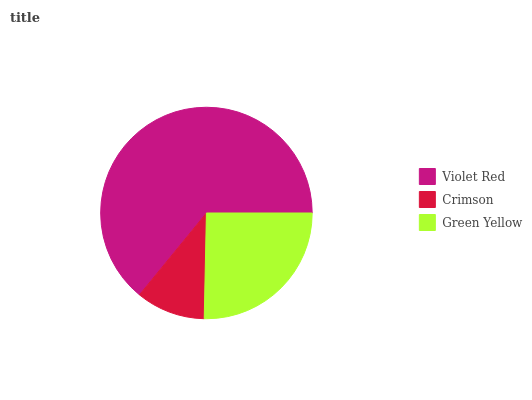Is Crimson the minimum?
Answer yes or no. Yes. Is Violet Red the maximum?
Answer yes or no. Yes. Is Green Yellow the minimum?
Answer yes or no. No. Is Green Yellow the maximum?
Answer yes or no. No. Is Green Yellow greater than Crimson?
Answer yes or no. Yes. Is Crimson less than Green Yellow?
Answer yes or no. Yes. Is Crimson greater than Green Yellow?
Answer yes or no. No. Is Green Yellow less than Crimson?
Answer yes or no. No. Is Green Yellow the high median?
Answer yes or no. Yes. Is Green Yellow the low median?
Answer yes or no. Yes. Is Violet Red the high median?
Answer yes or no. No. Is Violet Red the low median?
Answer yes or no. No. 